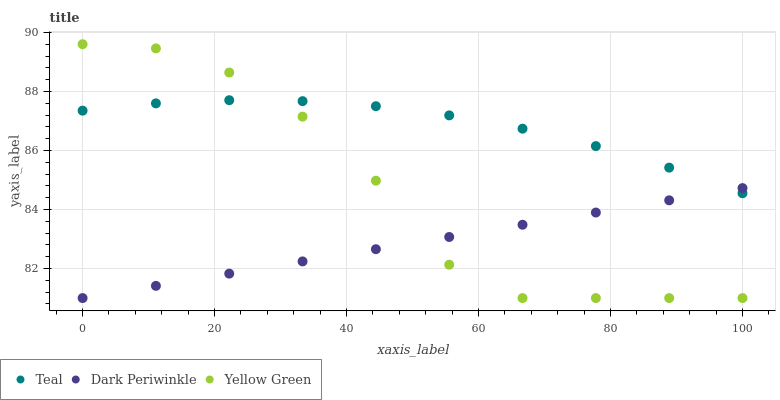Does Dark Periwinkle have the minimum area under the curve?
Answer yes or no. Yes. Does Teal have the maximum area under the curve?
Answer yes or no. Yes. Does Yellow Green have the minimum area under the curve?
Answer yes or no. No. Does Yellow Green have the maximum area under the curve?
Answer yes or no. No. Is Dark Periwinkle the smoothest?
Answer yes or no. Yes. Is Yellow Green the roughest?
Answer yes or no. Yes. Is Teal the smoothest?
Answer yes or no. No. Is Teal the roughest?
Answer yes or no. No. Does Dark Periwinkle have the lowest value?
Answer yes or no. Yes. Does Teal have the lowest value?
Answer yes or no. No. Does Yellow Green have the highest value?
Answer yes or no. Yes. Does Teal have the highest value?
Answer yes or no. No. Does Teal intersect Dark Periwinkle?
Answer yes or no. Yes. Is Teal less than Dark Periwinkle?
Answer yes or no. No. Is Teal greater than Dark Periwinkle?
Answer yes or no. No. 